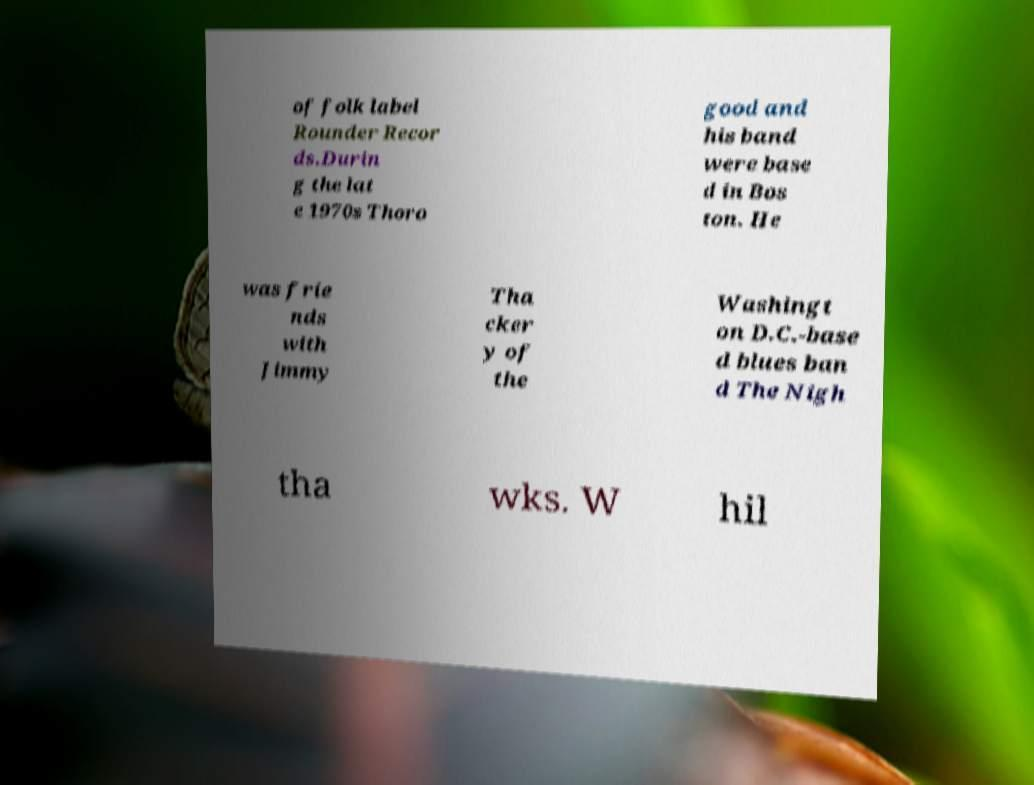Can you read and provide the text displayed in the image?This photo seems to have some interesting text. Can you extract and type it out for me? of folk label Rounder Recor ds.Durin g the lat e 1970s Thoro good and his band were base d in Bos ton. He was frie nds with Jimmy Tha cker y of the Washingt on D.C.-base d blues ban d The Nigh tha wks. W hil 